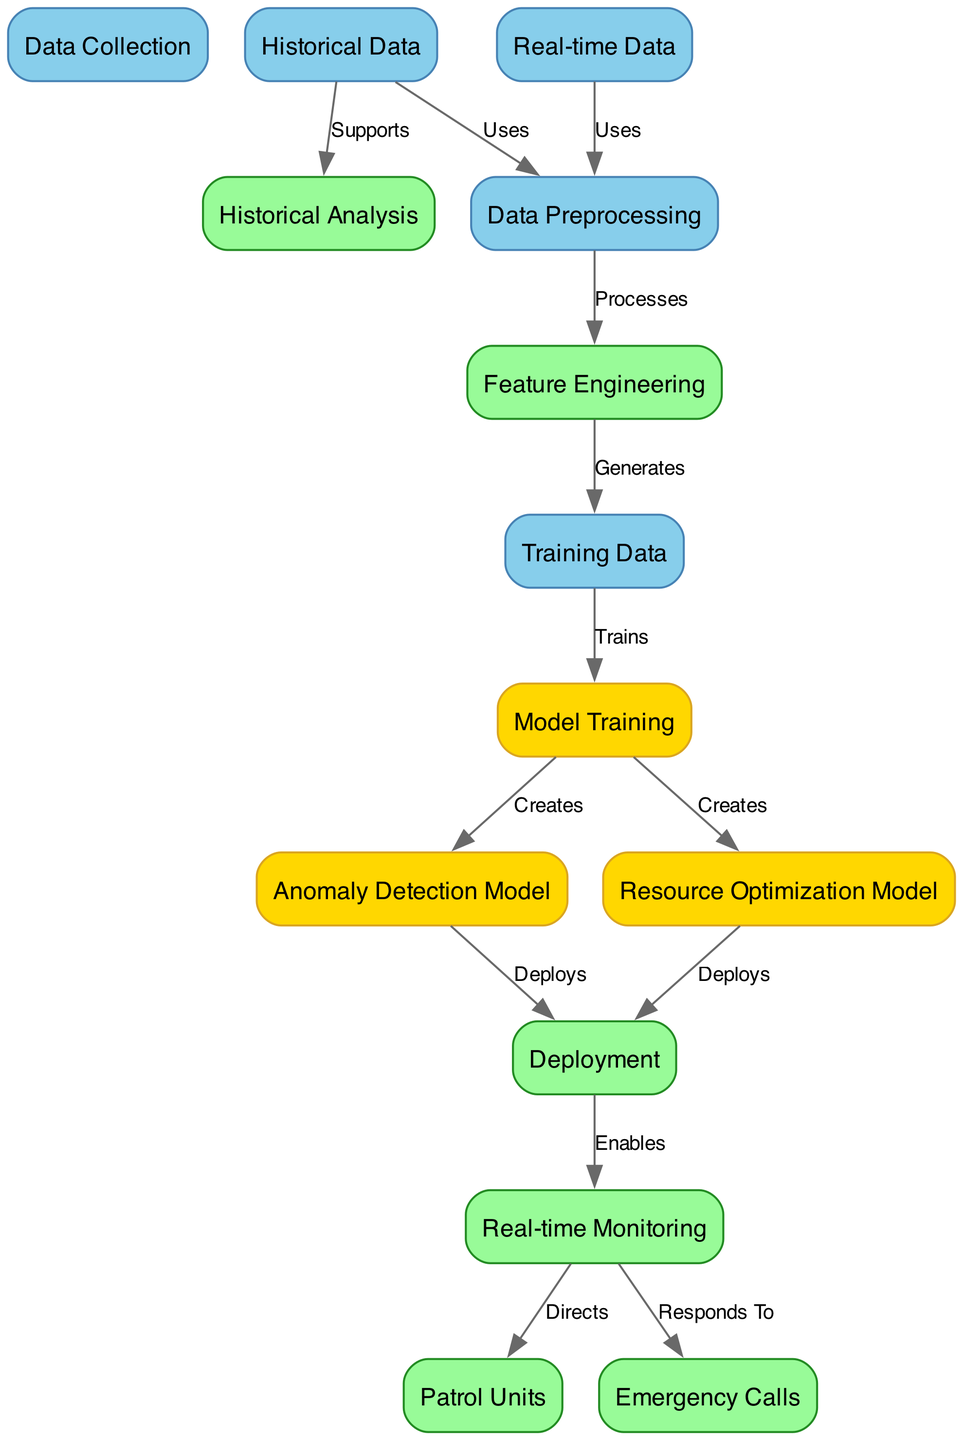What is the starting point for the data processing in the diagram? The diagram shows two nodes labeled "Historical Data" and "Real-time Data" that connect to the "Data Preprocessing" node, indicating that both types of data feed into the preprocessing stage.
Answer: Historical Data and Real-time Data How many nodes are present in the diagram? The diagram lists a total of 13 unique nodes, which include categories like data types, models, and monitoring processes.
Answer: 13 What model is created from the "Model Training" node? The "Model Training" node branches out into two different models: "Anomaly Detection Model" and "Resource Optimization Model", which means both are generated from the training process.
Answer: Anomaly Detection Model and Resource Optimization Model Which node directs actions to "Patrol Units"? The "Real-time Monitoring" node is shown to direct actions to the "Patrol Units", as indicated by the edge labeled "Directs".
Answer: Real-time Monitoring What is the function of the "Deployment" node in the context of the models? The "Deployment" node connects to both the "Anomaly Detection Model" and the "Resource Optimization Model", indicating that it facilitates the use of these models in a practical setting.
Answer: Enables the use of both models What data supports the "Historical Analysis" in the diagram? The "Historical Data" node has an edge labeled "Supports" that connects it to the "Historical Analysis" node, indicating that historical data plays a crucial role in analysis.
Answer: Historical Data What step comes immediately after "Feature Engineering"? From the diagram, it's clear that "Feature Engineering" leads to the "Training Data" generation, meaning that this step is the immediate next action.
Answer: Training Data Which two nodes connect to "Data Preprocessing"? Both the "Historical Data" and "Real-time Data" nodes make connections to "Data Preprocessing", indicating that they both undergo processing together.
Answer: Historical Data and Real-time Data What enables the "Real-time Monitoring"? The diagram indicates that both the "Anomaly Detection Model" and the "Resource Optimization Model" connect to the "Deployment" node, which then enables "Real-time Monitoring".
Answer: Deployment 